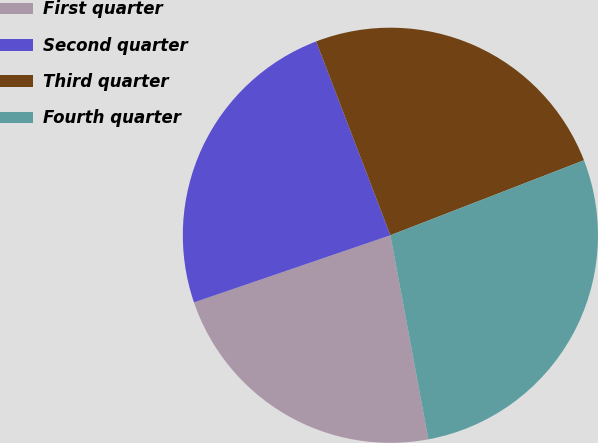Convert chart. <chart><loc_0><loc_0><loc_500><loc_500><pie_chart><fcel>First quarter<fcel>Second quarter<fcel>Third quarter<fcel>Fourth quarter<nl><fcel>22.69%<fcel>24.42%<fcel>24.94%<fcel>27.95%<nl></chart> 